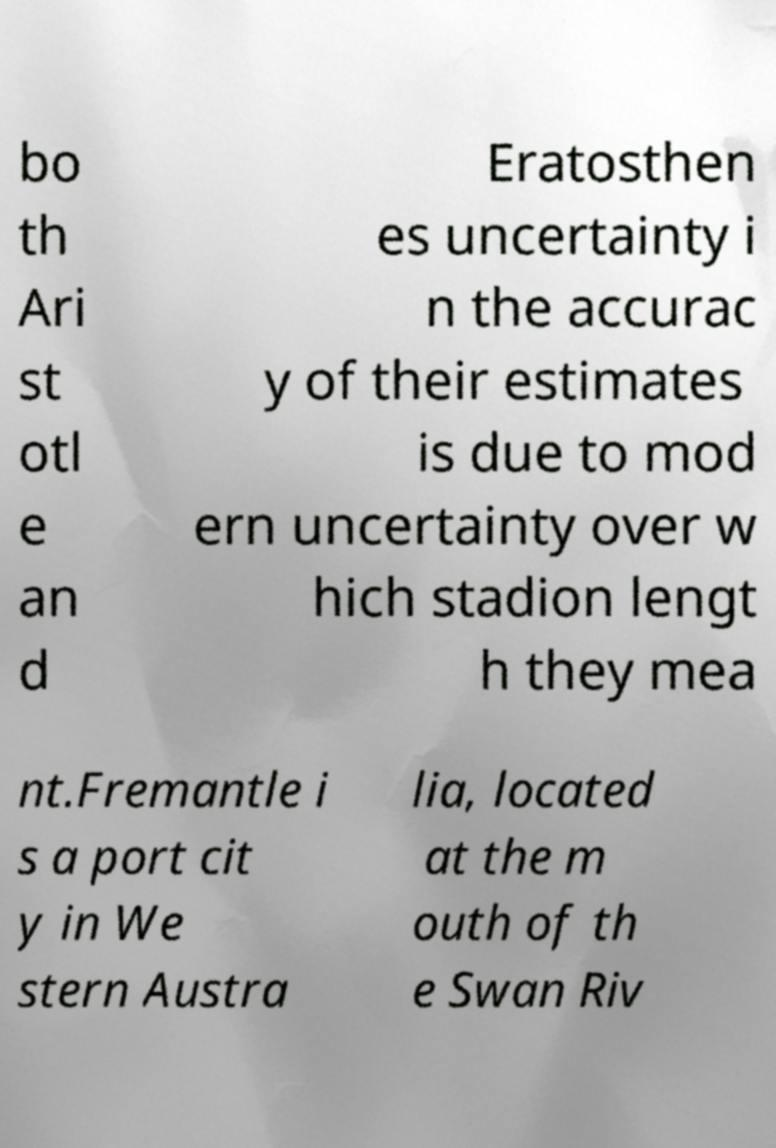Can you accurately transcribe the text from the provided image for me? bo th Ari st otl e an d Eratosthen es uncertainty i n the accurac y of their estimates is due to mod ern uncertainty over w hich stadion lengt h they mea nt.Fremantle i s a port cit y in We stern Austra lia, located at the m outh of th e Swan Riv 